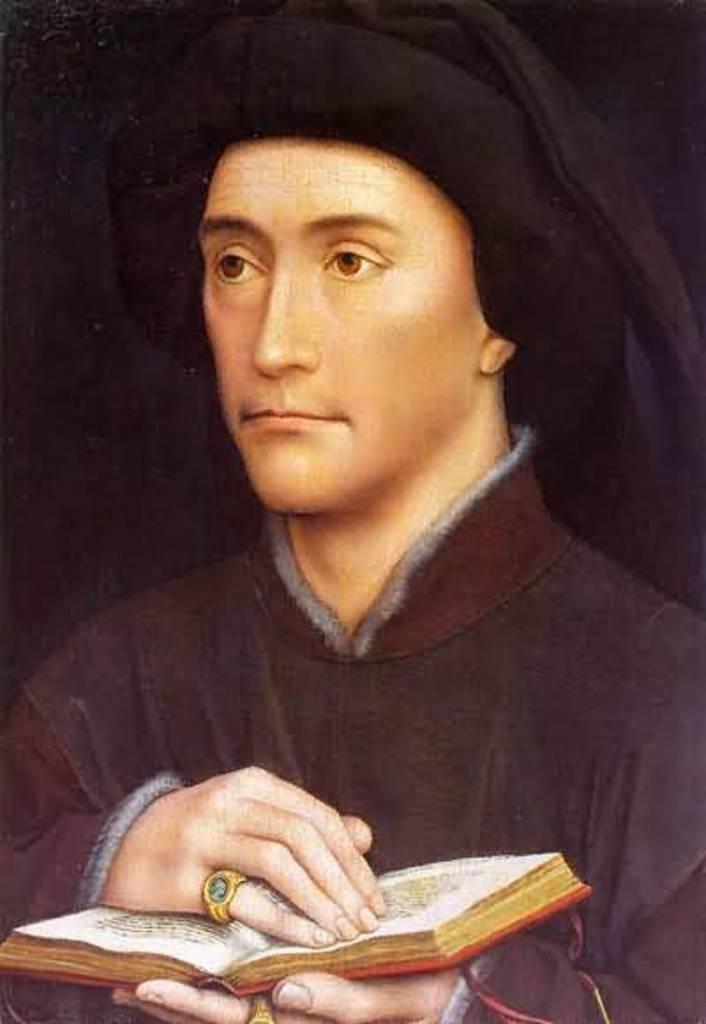Please provide a concise description of this image. In this image there is a painting of a person holding the book. 